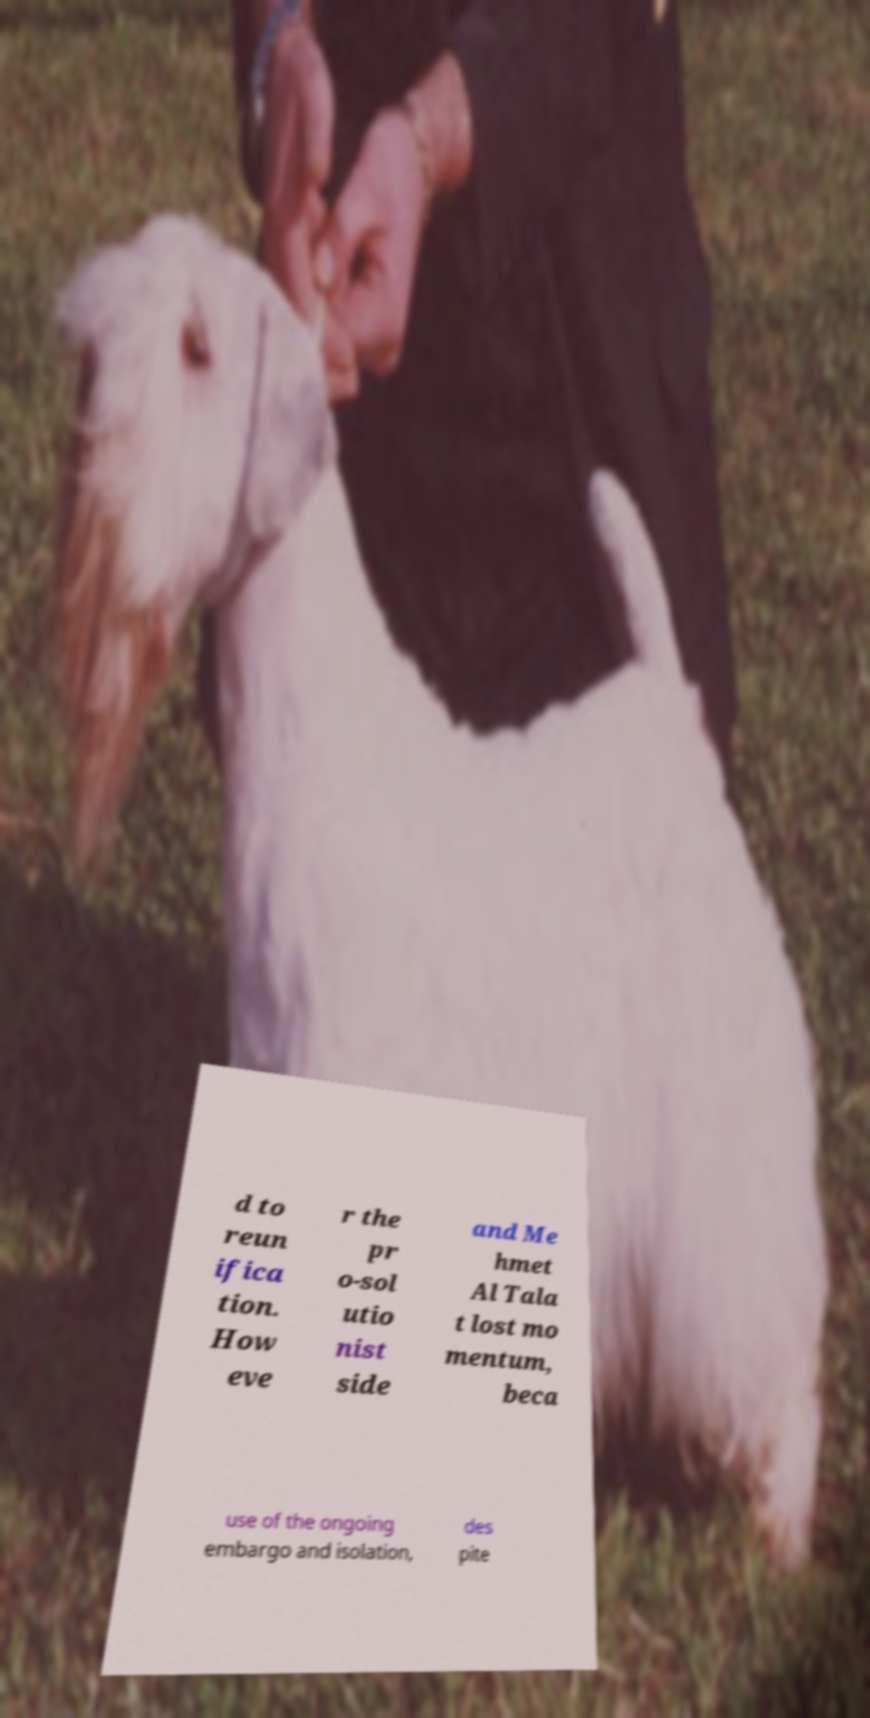Please identify and transcribe the text found in this image. d to reun ifica tion. How eve r the pr o-sol utio nist side and Me hmet Al Tala t lost mo mentum, beca use of the ongoing embargo and isolation, des pite 